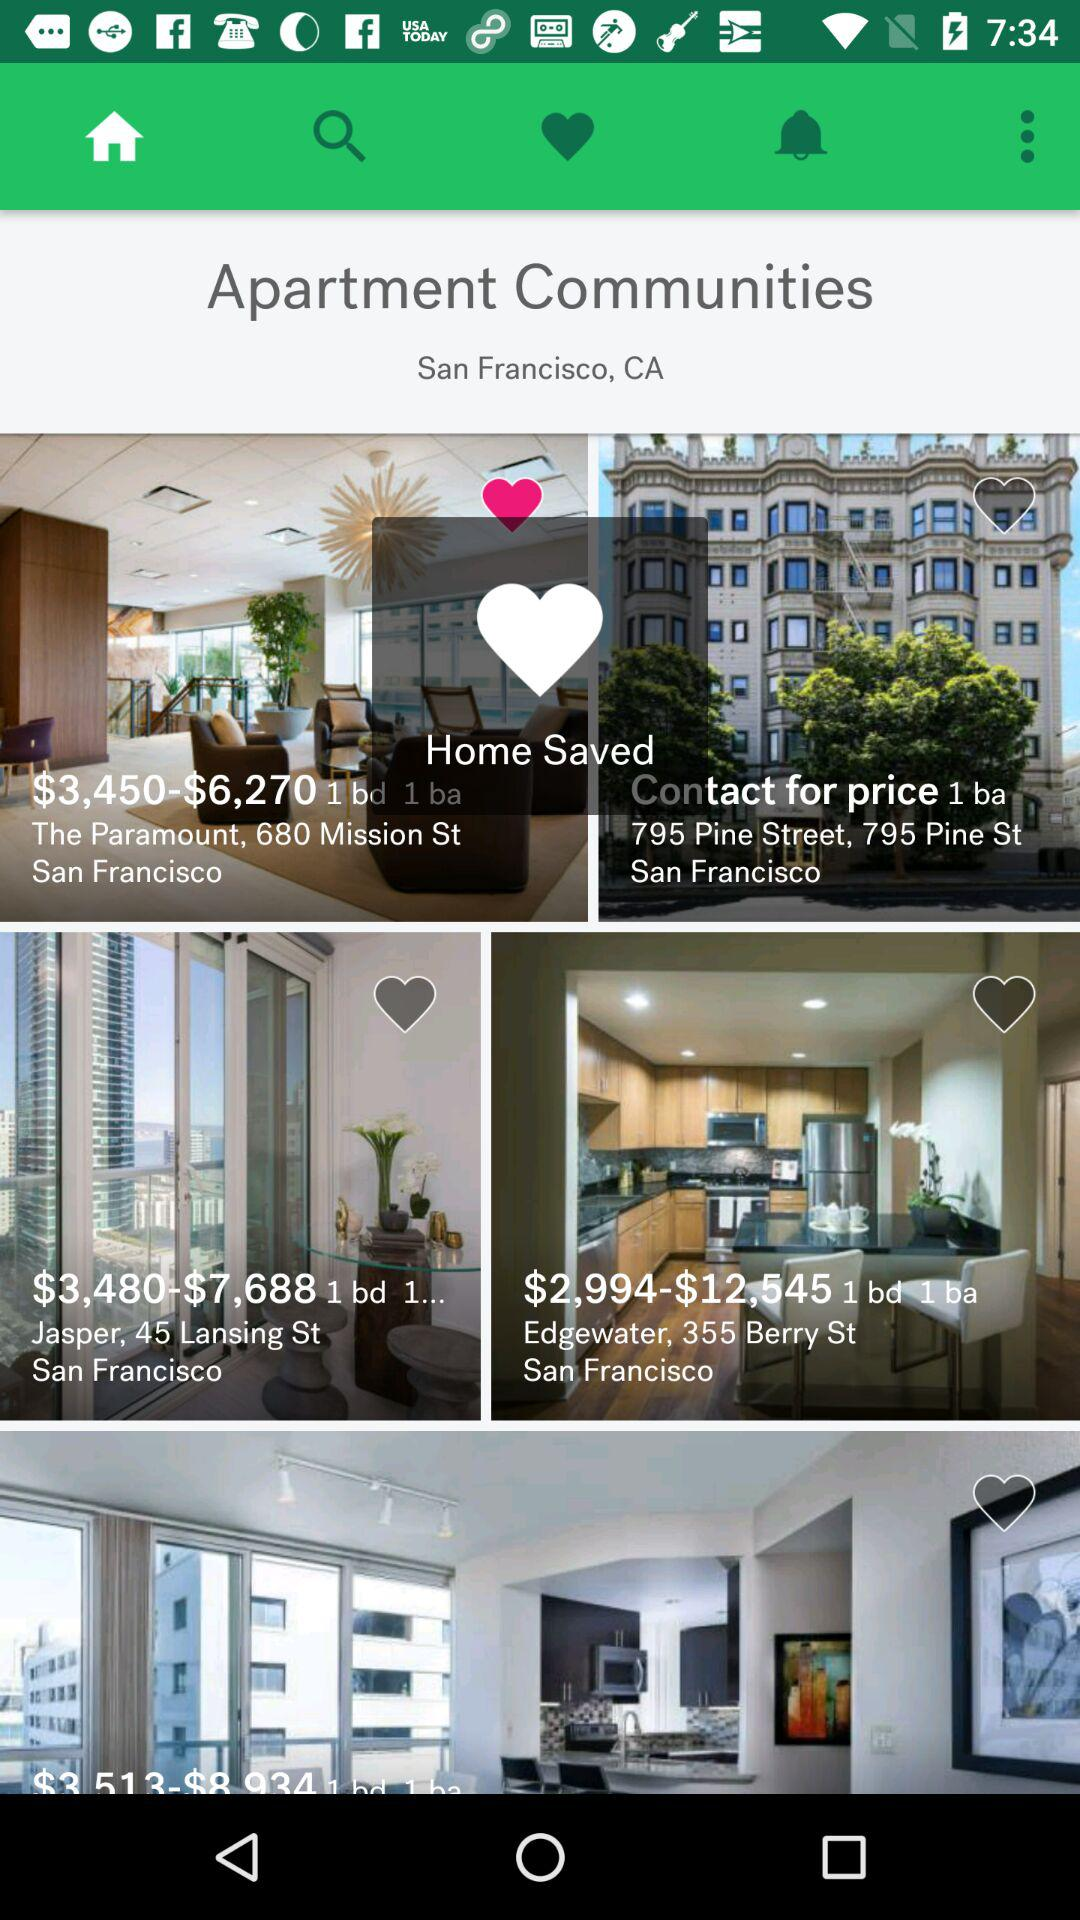What is the price range of Jasper apartments? The price range of Jasper apartments is between $3,480-$7,688. 